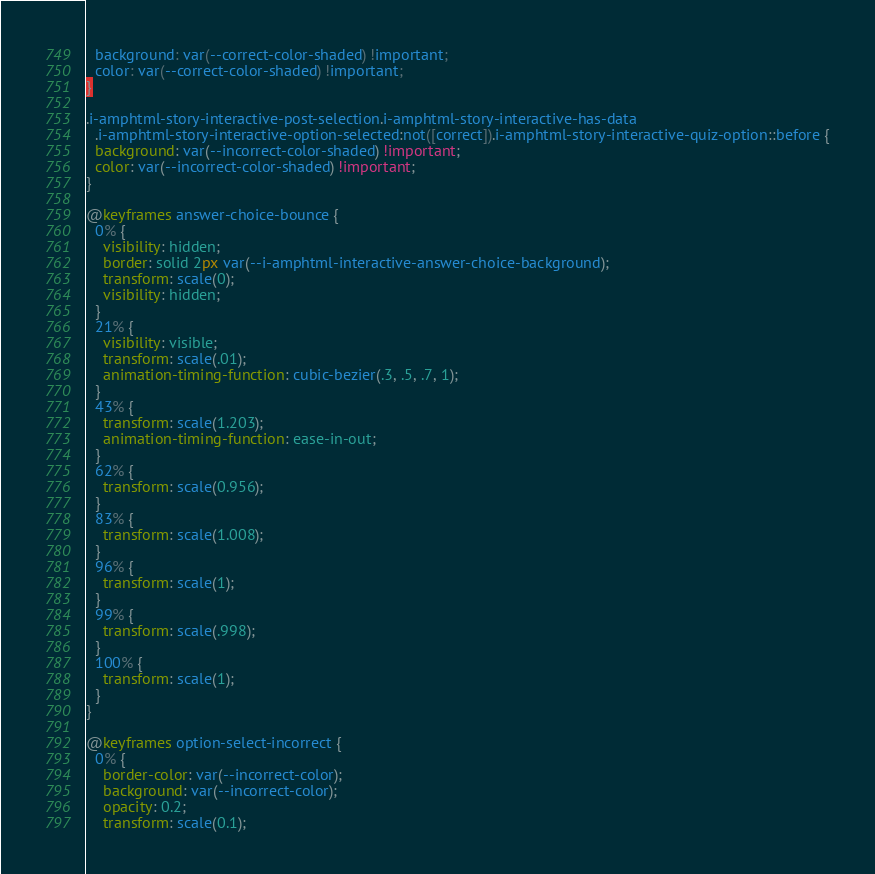Convert code to text. <code><loc_0><loc_0><loc_500><loc_500><_CSS_>  background: var(--correct-color-shaded) !important;
  color: var(--correct-color-shaded) !important;
}

.i-amphtml-story-interactive-post-selection.i-amphtml-story-interactive-has-data
  .i-amphtml-story-interactive-option-selected:not([correct]).i-amphtml-story-interactive-quiz-option::before {
  background: var(--incorrect-color-shaded) !important;
  color: var(--incorrect-color-shaded) !important;
}

@keyframes answer-choice-bounce {
  0% {
    visibility: hidden;
    border: solid 2px var(--i-amphtml-interactive-answer-choice-background);
    transform: scale(0);
    visibility: hidden;
  }
  21% {
    visibility: visible;
    transform: scale(.01);
    animation-timing-function: cubic-bezier(.3, .5, .7, 1);
  }
  43% {
    transform: scale(1.203);
    animation-timing-function: ease-in-out;
  }
  62% {
    transform: scale(0.956);
  }
  83% {
    transform: scale(1.008);
  }
  96% {
    transform: scale(1);
  }
  99% {
    transform: scale(.998);
  }
  100% {
    transform: scale(1);
  }
}

@keyframes option-select-incorrect {
  0% {
    border-color: var(--incorrect-color);
    background: var(--incorrect-color);
    opacity: 0.2;
    transform: scale(0.1);</code> 